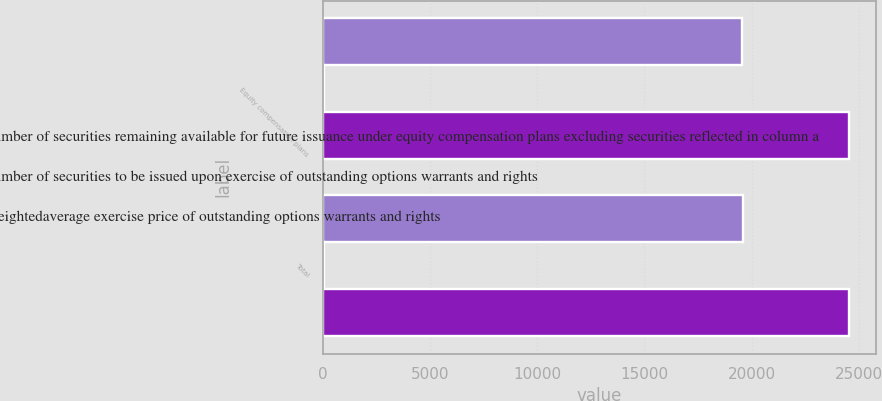Convert chart to OTSL. <chart><loc_0><loc_0><loc_500><loc_500><stacked_bar_chart><ecel><fcel>Equity compensation plans<fcel>Total<nl><fcel>c Number of securities remaining available for future issuance under equity compensation plans excluding securities reflected in column a<fcel>19548<fcel>19595<nl><fcel>a Number of securities to be issued upon exercise of outstanding options warrants and rights<fcel>49.61<fcel>49.61<nl><fcel>b Weightedaverage exercise price of outstanding options warrants and rights<fcel>24560<fcel>24560<nl></chart> 